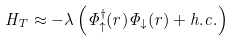Convert formula to latex. <formula><loc_0><loc_0><loc_500><loc_500>H _ { T } \approx - \lambda \left ( \Phi _ { \uparrow } ^ { \dagger } ( r ) \Phi _ { \downarrow } ( r ) + h . c . \right )</formula> 